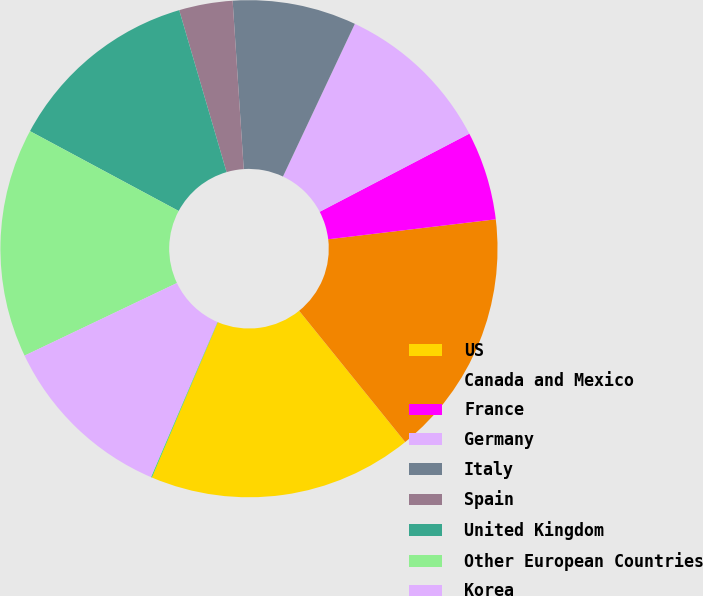<chart> <loc_0><loc_0><loc_500><loc_500><pie_chart><fcel>US<fcel>Canada and Mexico<fcel>France<fcel>Germany<fcel>Italy<fcel>Spain<fcel>United Kingdom<fcel>Other European Countries<fcel>Korea<fcel>Thailand<nl><fcel>17.21%<fcel>16.07%<fcel>5.77%<fcel>10.34%<fcel>8.05%<fcel>3.48%<fcel>12.63%<fcel>14.92%<fcel>11.49%<fcel>0.04%<nl></chart> 